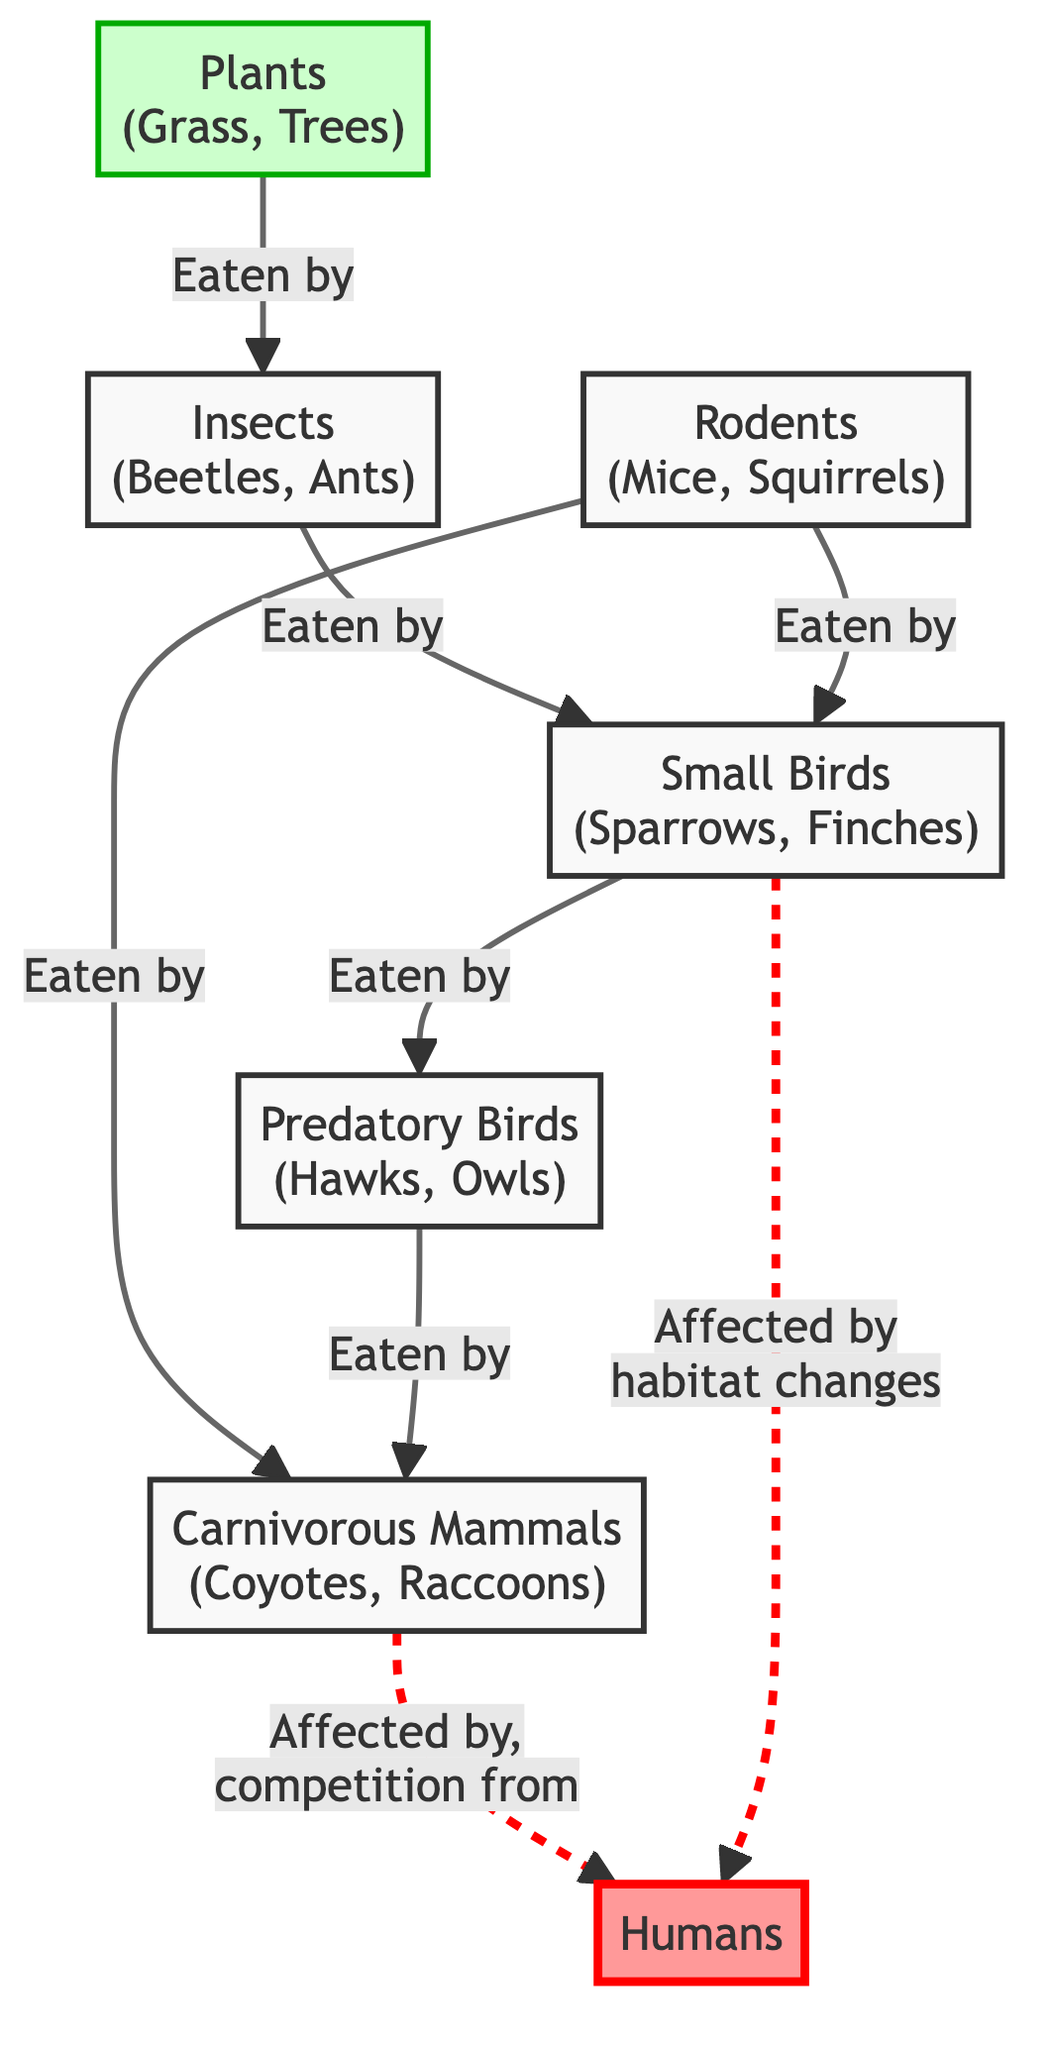What is the primary producer in the food chain? The primary producer in the food chain, as indicated in the diagram, is "Plants (Grass, Trees)," which serves as the base for the food web.
Answer: Plants (Grass, Trees) How many types of predators are present in the diagram? By examining the diagram, there are two types of predators depicted: "Predatory Birds (Hawks, Owls)" and "Carnivorous Mammals (Coyotes, Raccoons)," making a total of two.
Answer: 2 Which group is directly affected by habitat changes? The diagram clearly shows that "Small Birds (Sparrows, Finches)" are directly affected by habitat changes, indicated by the dashed line connecting them to "Humans."
Answer: Small Birds (Sparrows, Finches) What is the relationship between insects and small birds? The diagram depicts that insects are eaten by small birds, which is a direct predator-prey relationship shown with a solid arrow.
Answer: Eaten by Which two groups compete due to human activity? The relationship in the diagram indicates that "Carnivorous Mammals (Coyotes, Raccoons)" are affected by humans through competition, as indicated by the dashed line connecting them.
Answer: Carnivorous Mammals (Coyotes, Raccoons) Which group consumes rodents in the food chain? According to the diagram, small birds consume rodents, which is shown by the solid arrow directing from "Rodents" to "Small Birds."
Answer: Small Birds (Sparrows, Finches) How many total interactions (edges) are shown in the diagram? By tallying the directed arrows in the diagram, there are a total of six interactions that define the predator-prey dynamics.
Answer: 6 What type of mammals are represented as carnivores? The diagram specifically identifies "Coyotes" and "Raccoons" as the carnivorous mammals involved in the food chain, as evident by the labeled node.
Answer: Coyotes, Raccoons 